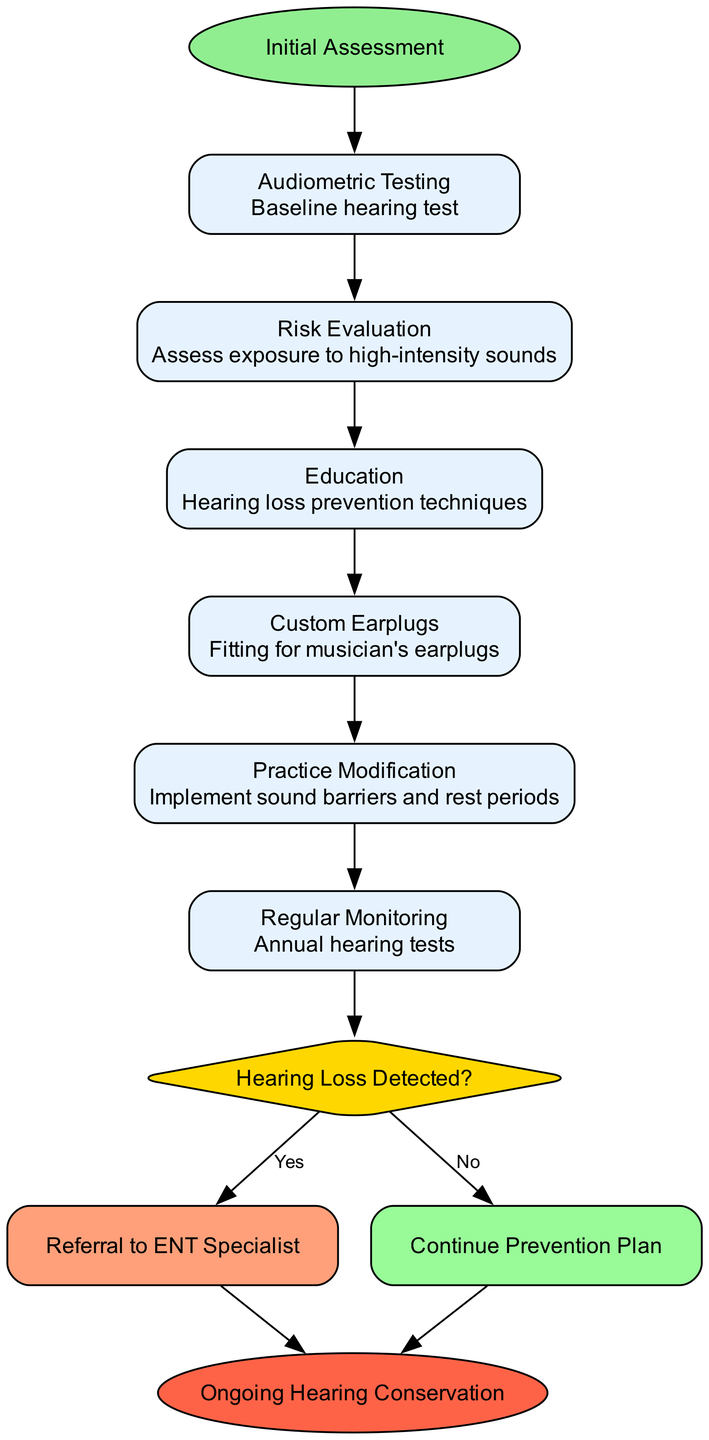What is the starting point of the clinical pathway? The starting point is clearly indicated at the top of the diagram and is labeled as "Initial Assessment." This represents the first step in the clinical pathway.
Answer: Initial Assessment How many steps are there in the clinical pathway? The diagram includes a total of six steps listed under the "steps" section. These steps are connected in a linear sequence leading towards a decision point.
Answer: 6 What is the last step before the decision point? The last step shown before the decision point is "Regular Monitoring" which is the sixth step in the pathway. It is crucial for ongoing assessment.
Answer: Regular Monitoring What happens if hearing loss is detected? If hearing loss is detected, the pathway indicates a referral to "ENT Specialist," which is specified in the decision outcome labeled "Yes."
Answer: Referral to ENT Specialist What is indicated by the "no" at the decision point? The "no" label at the decision point specifies that if no hearing loss is detected, the next action is to "Continue Prevention Plan," meaning ongoing preventive measures will be followed.
Answer: Continue Prevention Plan How do the steps connect to the decision point? Each step directly connects to the next step with arrows, leading ultimately to the decision point, indicating a sequential flow of the clinical pathway for hearing conservation.
Answer: Sequentially What type of node represents the final endpoint of the clinical pathway? The final endpoint of the clinical pathway is represented by an ellipse shape in the diagram as indicated by the "end" node, which concludes the process.
Answer: Ellipse What type of action is represented by "Education"? "Education" is listed as a preventive action and represents a step focused on informing participants about hearing loss prevention techniques. This indicates it is part of the proactive measures taken.
Answer: Preventive action How does "Custom Earplugs" relate to the other steps? "Custom Earplugs" is part of the preventive measures and follows the "Education" step, suggesting that once participants are educated about prevention, they will receive custom fittings for earplugs, enhancing their hearing protection.
Answer: Preventive measure following education 